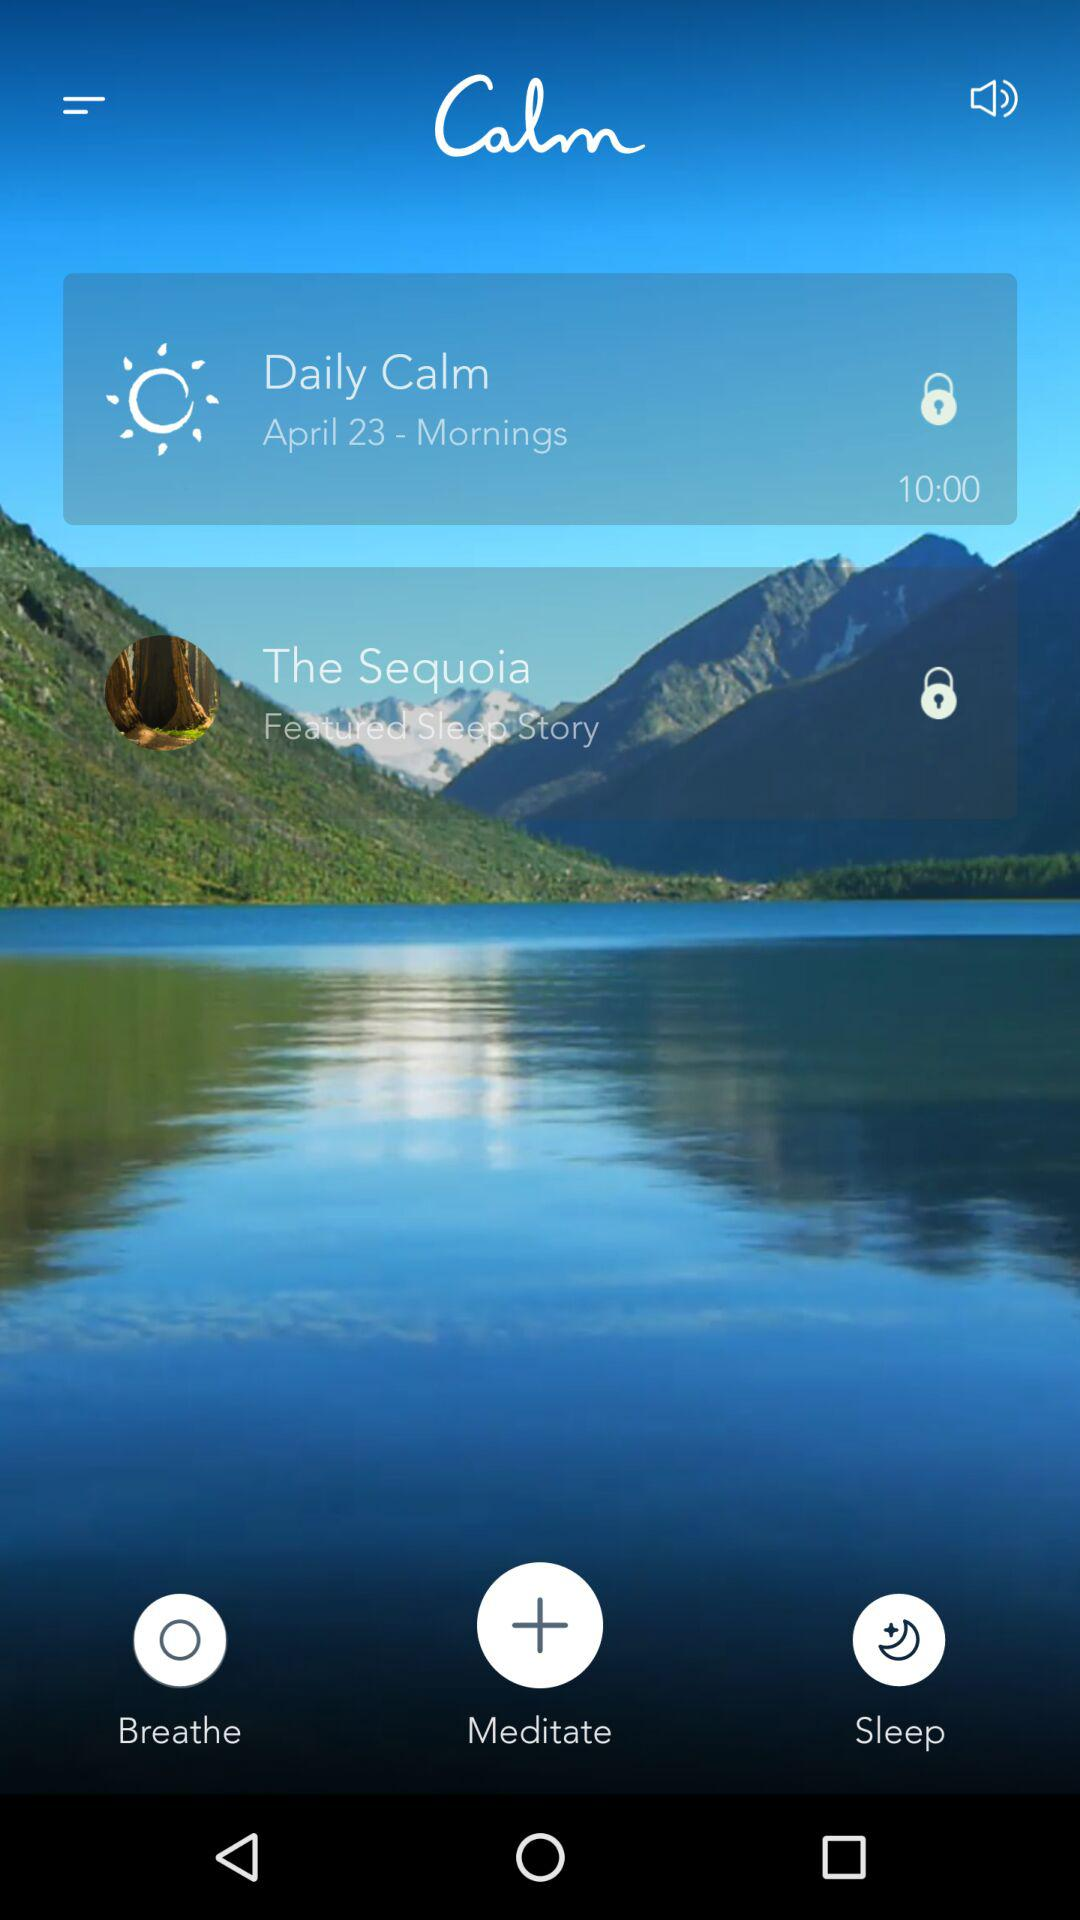What is the given time? The given time is 10:00. 